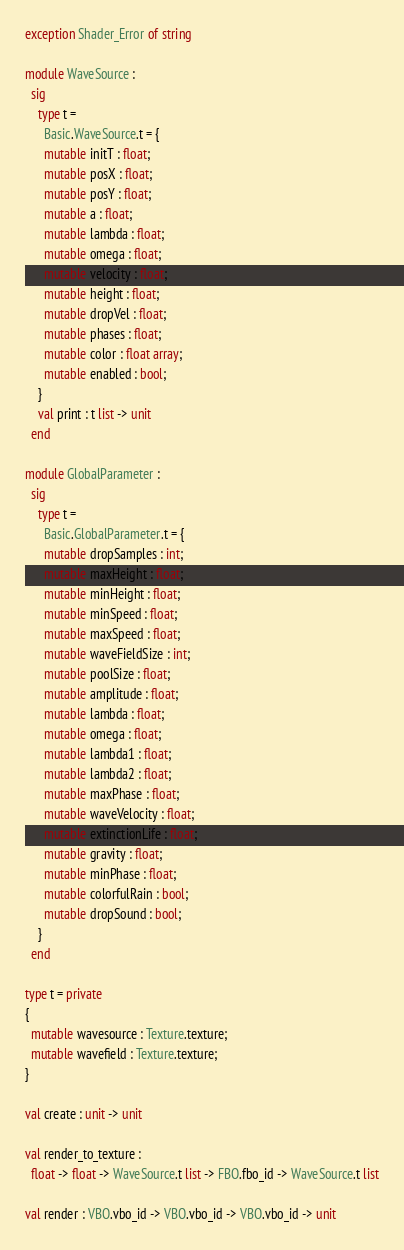Convert code to text. <code><loc_0><loc_0><loc_500><loc_500><_OCaml_>exception Shader_Error of string

module WaveSource :
  sig
    type t =
      Basic.WaveSource.t = {
      mutable initT : float;
      mutable posX : float;
      mutable posY : float;
      mutable a : float;
      mutable lambda : float;
      mutable omega : float;
      mutable velocity : float;
      mutable height : float;
      mutable dropVel : float;
      mutable phases : float;
      mutable color : float array;
      mutable enabled : bool;
    }
    val print : t list -> unit
  end

module GlobalParameter :
  sig
    type t =
      Basic.GlobalParameter.t = {
      mutable dropSamples : int;
      mutable maxHeight : float;
      mutable minHeight : float;
      mutable minSpeed : float;
      mutable maxSpeed : float;
      mutable waveFieldSize : int;
      mutable poolSize : float;
      mutable amplitude : float;
      mutable lambda : float;
      mutable omega : float;
      mutable lambda1 : float;
      mutable lambda2 : float;
      mutable maxPhase : float;
      mutable waveVelocity : float;
      mutable extinctionLife : float;
      mutable gravity : float;
      mutable minPhase : float;
      mutable colorfulRain : bool;
      mutable dropSound : bool;
    }
  end

type t = private
{
  mutable wavesource : Texture.texture;
  mutable wavefield : Texture.texture;
}

val create : unit -> unit

val render_to_texture :
  float -> float -> WaveSource.t list -> FBO.fbo_id -> WaveSource.t list

val render : VBO.vbo_id -> VBO.vbo_id -> VBO.vbo_id -> unit
</code> 